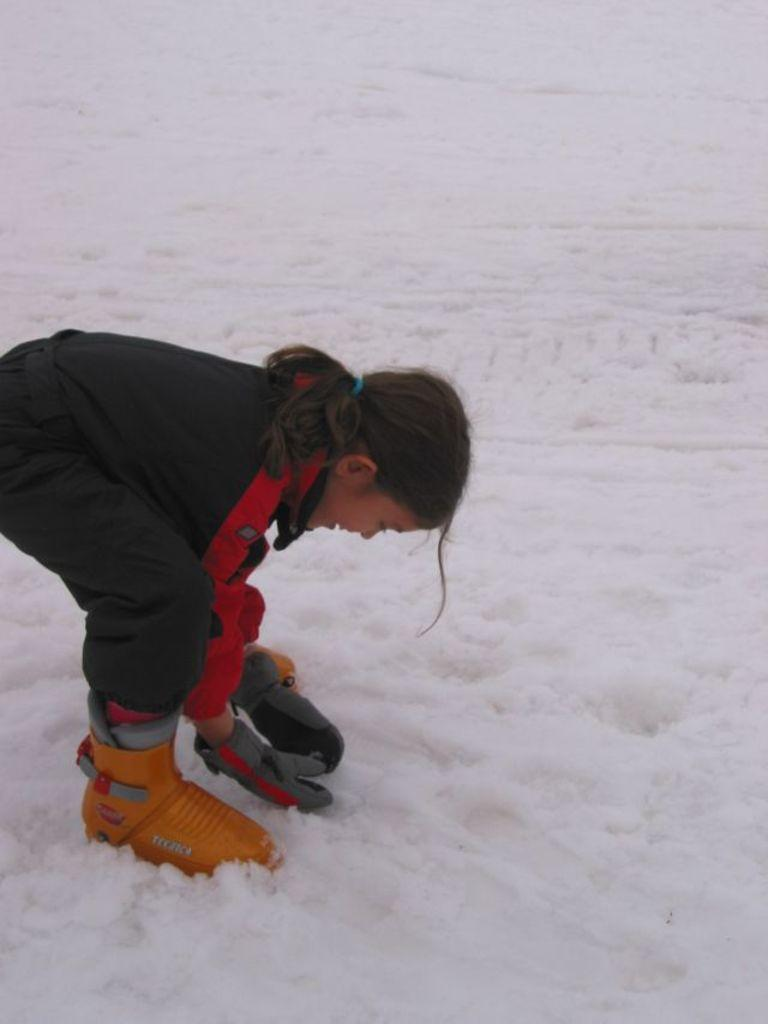Who is the main subject in the image? There is a little girl in the image. What is the girl standing on? The girl is standing on the surface of the snow. What is the girl doing with her hands? The girl has placed her hands above the snow. How many frogs can be seen hopping around the girl in the image? There are no frogs present in the image. What type of dog is sitting next to the girl in the image? There is no dog present in the image. 